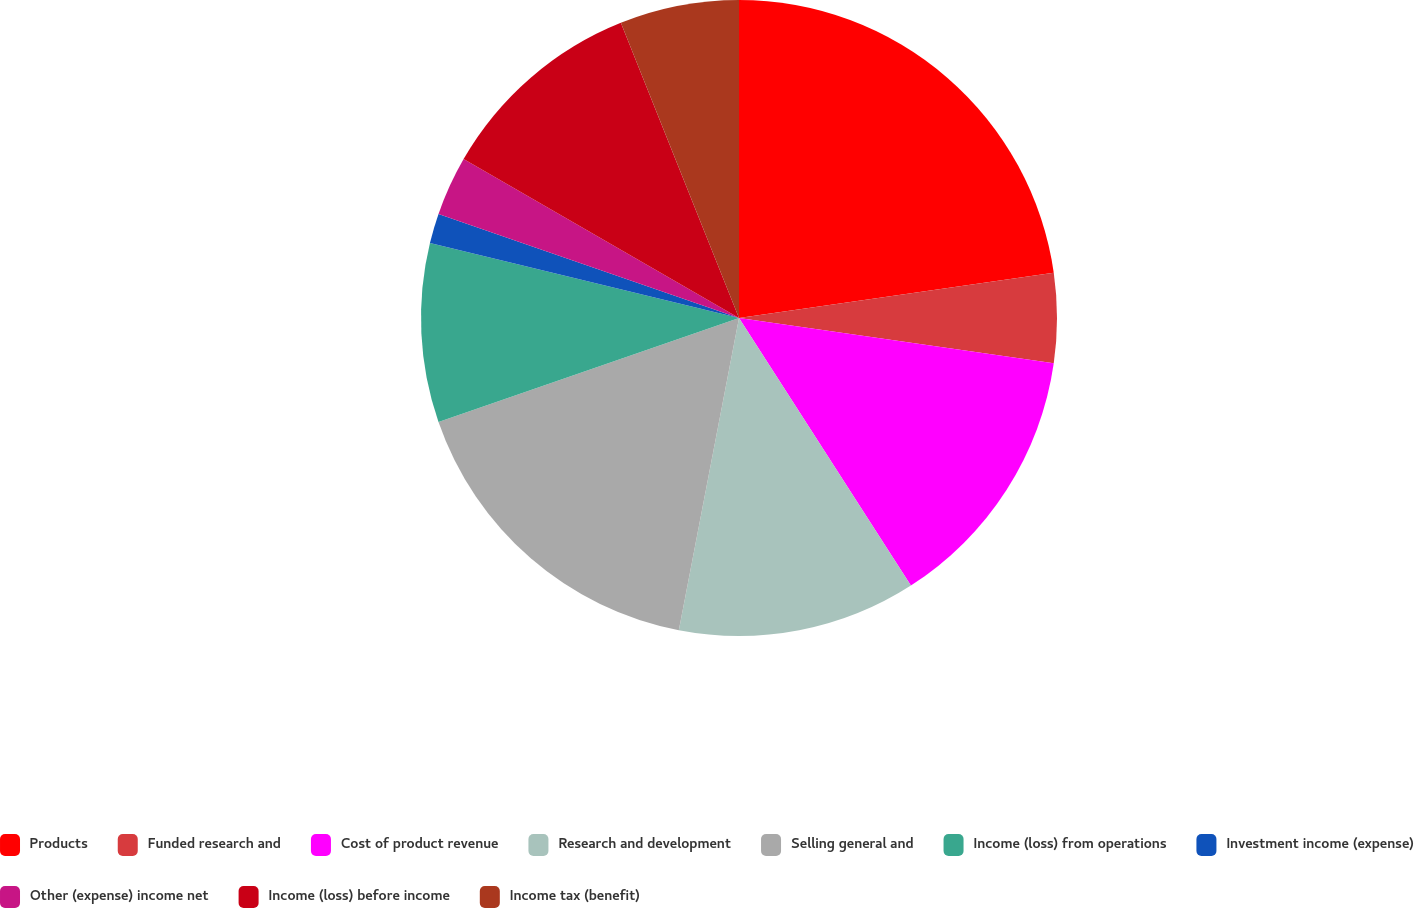<chart> <loc_0><loc_0><loc_500><loc_500><pie_chart><fcel>Products<fcel>Funded research and<fcel>Cost of product revenue<fcel>Research and development<fcel>Selling general and<fcel>Income (loss) from operations<fcel>Investment income (expense)<fcel>Other (expense) income net<fcel>Income (loss) before income<fcel>Income tax (benefit)<nl><fcel>22.73%<fcel>4.55%<fcel>13.64%<fcel>12.12%<fcel>16.67%<fcel>9.09%<fcel>1.52%<fcel>3.03%<fcel>10.61%<fcel>6.06%<nl></chart> 